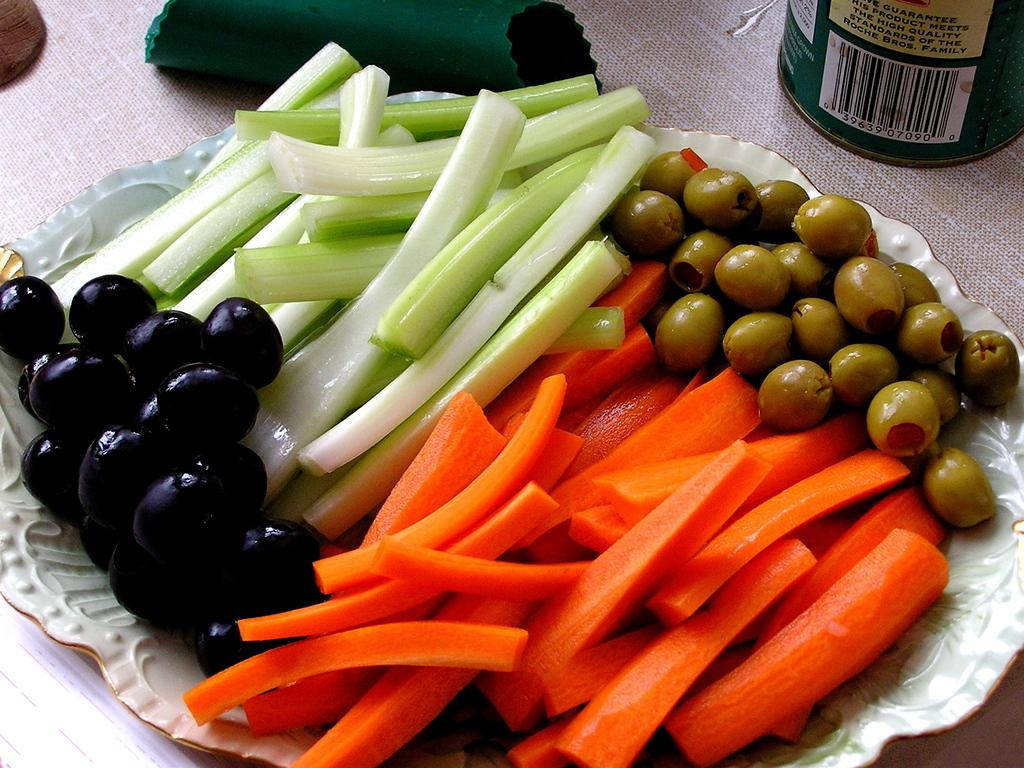What type of food items can be seen in the image? There are olives and sliced carrots in the image. What category of food do these items belong to? These items are fruits and vegetables. Where are the fruits and vegetables located in the image? They are in a tray on a table. What is beside the table in the image? There is a tree beside the table. What is beside the tree in the image? There is a can beside the tree, and there are other objects beside the tree as well. What type of building can be seen in the image? There is no building present in the image. What holiday is being celebrated in the image? There is no indication of a holiday being celebrated in the image. 